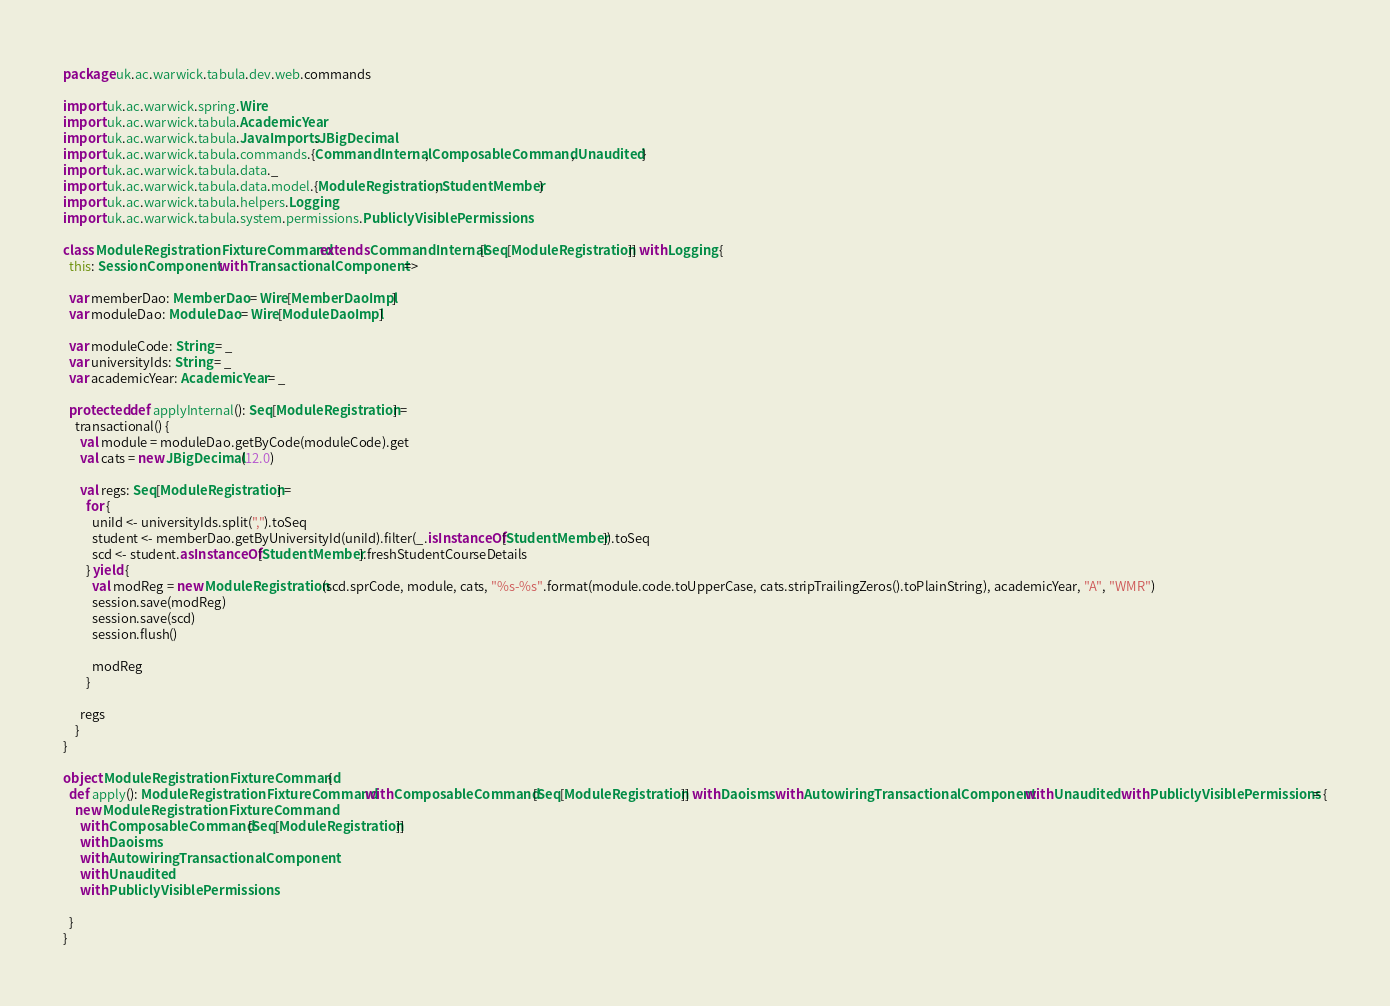<code> <loc_0><loc_0><loc_500><loc_500><_Scala_>package uk.ac.warwick.tabula.dev.web.commands

import uk.ac.warwick.spring.Wire
import uk.ac.warwick.tabula.AcademicYear
import uk.ac.warwick.tabula.JavaImports.JBigDecimal
import uk.ac.warwick.tabula.commands.{CommandInternal, ComposableCommand, Unaudited}
import uk.ac.warwick.tabula.data._
import uk.ac.warwick.tabula.data.model.{ModuleRegistration, StudentMember}
import uk.ac.warwick.tabula.helpers.Logging
import uk.ac.warwick.tabula.system.permissions.PubliclyVisiblePermissions

class ModuleRegistrationFixtureCommand extends CommandInternal[Seq[ModuleRegistration]] with Logging {
  this: SessionComponent with TransactionalComponent =>

  var memberDao: MemberDao = Wire[MemberDaoImpl]
  var moduleDao: ModuleDao = Wire[ModuleDaoImpl]

  var moduleCode: String = _
  var universityIds: String = _
  var academicYear: AcademicYear = _

  protected def applyInternal(): Seq[ModuleRegistration] =
    transactional() {
      val module = moduleDao.getByCode(moduleCode).get
      val cats = new JBigDecimal(12.0)

      val regs: Seq[ModuleRegistration] =
        for {
          uniId <- universityIds.split(",").toSeq
          student <- memberDao.getByUniversityId(uniId).filter(_.isInstanceOf[StudentMember]).toSeq
          scd <- student.asInstanceOf[StudentMember].freshStudentCourseDetails
        } yield {
          val modReg = new ModuleRegistration(scd.sprCode, module, cats, "%s-%s".format(module.code.toUpperCase, cats.stripTrailingZeros().toPlainString), academicYear, "A", "WMR")
          session.save(modReg)
          session.save(scd)
          session.flush()

          modReg
        }

      regs
    }
}

object ModuleRegistrationFixtureCommand {
  def apply(): ModuleRegistrationFixtureCommand with ComposableCommand[Seq[ModuleRegistration]] with Daoisms with AutowiringTransactionalComponent with Unaudited with PubliclyVisiblePermissions = {
    new ModuleRegistrationFixtureCommand
      with ComposableCommand[Seq[ModuleRegistration]]
      with Daoisms
      with AutowiringTransactionalComponent
      with Unaudited
      with PubliclyVisiblePermissions

  }
}
</code> 